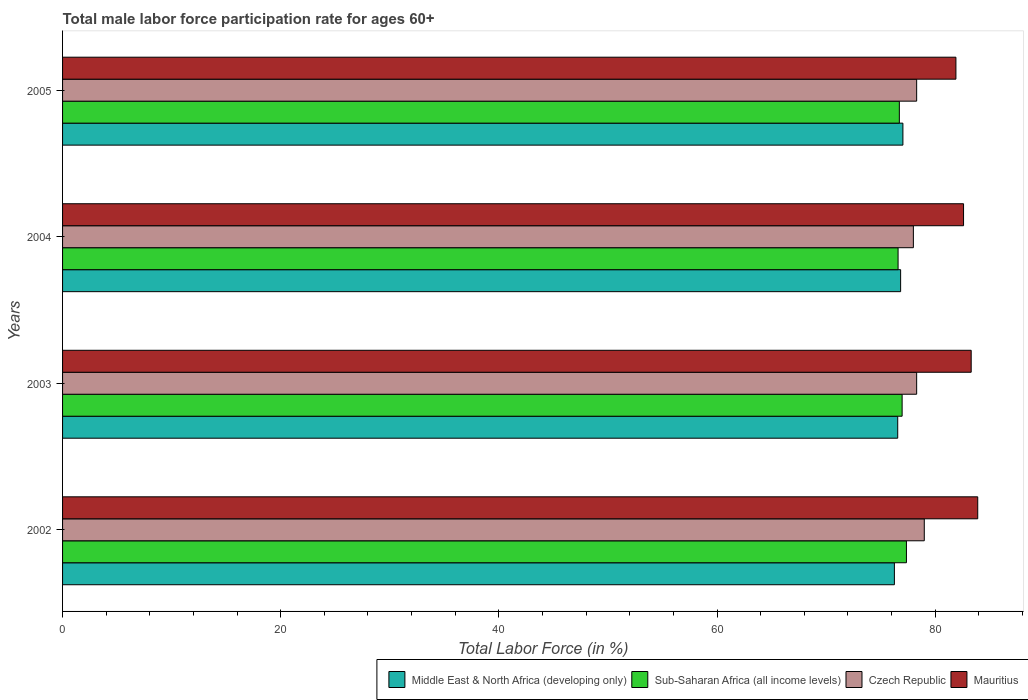How many bars are there on the 1st tick from the bottom?
Ensure brevity in your answer.  4. What is the male labor force participation rate in Sub-Saharan Africa (all income levels) in 2005?
Ensure brevity in your answer.  76.71. Across all years, what is the maximum male labor force participation rate in Sub-Saharan Africa (all income levels)?
Offer a terse response. 77.36. Across all years, what is the minimum male labor force participation rate in Czech Republic?
Your response must be concise. 78. What is the total male labor force participation rate in Sub-Saharan Africa (all income levels) in the graph?
Provide a short and direct response. 307.64. What is the difference between the male labor force participation rate in Middle East & North Africa (developing only) in 2002 and that in 2003?
Your answer should be very brief. -0.31. What is the difference between the male labor force participation rate in Czech Republic in 2005 and the male labor force participation rate in Middle East & North Africa (developing only) in 2002?
Provide a succinct answer. 2.04. What is the average male labor force participation rate in Middle East & North Africa (developing only) per year?
Your answer should be very brief. 76.67. In the year 2004, what is the difference between the male labor force participation rate in Mauritius and male labor force participation rate in Czech Republic?
Provide a succinct answer. 4.6. In how many years, is the male labor force participation rate in Sub-Saharan Africa (all income levels) greater than 72 %?
Your answer should be very brief. 4. What is the ratio of the male labor force participation rate in Middle East & North Africa (developing only) in 2004 to that in 2005?
Your answer should be very brief. 1. Is the male labor force participation rate in Mauritius in 2002 less than that in 2004?
Provide a succinct answer. No. Is the difference between the male labor force participation rate in Mauritius in 2002 and 2005 greater than the difference between the male labor force participation rate in Czech Republic in 2002 and 2005?
Your response must be concise. Yes. What is the difference between the highest and the second highest male labor force participation rate in Sub-Saharan Africa (all income levels)?
Keep it short and to the point. 0.4. What is the difference between the highest and the lowest male labor force participation rate in Mauritius?
Give a very brief answer. 2. In how many years, is the male labor force participation rate in Czech Republic greater than the average male labor force participation rate in Czech Republic taken over all years?
Offer a very short reply. 1. Is it the case that in every year, the sum of the male labor force participation rate in Sub-Saharan Africa (all income levels) and male labor force participation rate in Czech Republic is greater than the sum of male labor force participation rate in Middle East & North Africa (developing only) and male labor force participation rate in Mauritius?
Make the answer very short. No. What does the 2nd bar from the top in 2002 represents?
Your response must be concise. Czech Republic. What does the 2nd bar from the bottom in 2005 represents?
Your response must be concise. Sub-Saharan Africa (all income levels). Are all the bars in the graph horizontal?
Provide a succinct answer. Yes. What is the difference between two consecutive major ticks on the X-axis?
Your response must be concise. 20. Are the values on the major ticks of X-axis written in scientific E-notation?
Offer a very short reply. No. Does the graph contain any zero values?
Your answer should be very brief. No. How many legend labels are there?
Your response must be concise. 4. How are the legend labels stacked?
Provide a short and direct response. Horizontal. What is the title of the graph?
Provide a short and direct response. Total male labor force participation rate for ages 60+. What is the label or title of the X-axis?
Give a very brief answer. Total Labor Force (in %). What is the Total Labor Force (in %) of Middle East & North Africa (developing only) in 2002?
Give a very brief answer. 76.26. What is the Total Labor Force (in %) in Sub-Saharan Africa (all income levels) in 2002?
Provide a short and direct response. 77.36. What is the Total Labor Force (in %) in Czech Republic in 2002?
Give a very brief answer. 79. What is the Total Labor Force (in %) of Mauritius in 2002?
Ensure brevity in your answer.  83.9. What is the Total Labor Force (in %) in Middle East & North Africa (developing only) in 2003?
Provide a succinct answer. 76.57. What is the Total Labor Force (in %) of Sub-Saharan Africa (all income levels) in 2003?
Offer a terse response. 76.97. What is the Total Labor Force (in %) in Czech Republic in 2003?
Make the answer very short. 78.3. What is the Total Labor Force (in %) of Mauritius in 2003?
Ensure brevity in your answer.  83.3. What is the Total Labor Force (in %) in Middle East & North Africa (developing only) in 2004?
Give a very brief answer. 76.83. What is the Total Labor Force (in %) in Sub-Saharan Africa (all income levels) in 2004?
Make the answer very short. 76.6. What is the Total Labor Force (in %) of Mauritius in 2004?
Offer a terse response. 82.6. What is the Total Labor Force (in %) of Middle East & North Africa (developing only) in 2005?
Give a very brief answer. 77.04. What is the Total Labor Force (in %) of Sub-Saharan Africa (all income levels) in 2005?
Your response must be concise. 76.71. What is the Total Labor Force (in %) in Czech Republic in 2005?
Your answer should be very brief. 78.3. What is the Total Labor Force (in %) in Mauritius in 2005?
Ensure brevity in your answer.  81.9. Across all years, what is the maximum Total Labor Force (in %) in Middle East & North Africa (developing only)?
Provide a succinct answer. 77.04. Across all years, what is the maximum Total Labor Force (in %) in Sub-Saharan Africa (all income levels)?
Offer a very short reply. 77.36. Across all years, what is the maximum Total Labor Force (in %) of Czech Republic?
Provide a short and direct response. 79. Across all years, what is the maximum Total Labor Force (in %) of Mauritius?
Offer a very short reply. 83.9. Across all years, what is the minimum Total Labor Force (in %) of Middle East & North Africa (developing only)?
Provide a short and direct response. 76.26. Across all years, what is the minimum Total Labor Force (in %) of Sub-Saharan Africa (all income levels)?
Make the answer very short. 76.6. Across all years, what is the minimum Total Labor Force (in %) in Czech Republic?
Your answer should be very brief. 78. Across all years, what is the minimum Total Labor Force (in %) in Mauritius?
Provide a short and direct response. 81.9. What is the total Total Labor Force (in %) in Middle East & North Africa (developing only) in the graph?
Keep it short and to the point. 306.7. What is the total Total Labor Force (in %) of Sub-Saharan Africa (all income levels) in the graph?
Provide a succinct answer. 307.64. What is the total Total Labor Force (in %) in Czech Republic in the graph?
Your answer should be very brief. 313.6. What is the total Total Labor Force (in %) of Mauritius in the graph?
Your answer should be compact. 331.7. What is the difference between the Total Labor Force (in %) in Middle East & North Africa (developing only) in 2002 and that in 2003?
Provide a short and direct response. -0.31. What is the difference between the Total Labor Force (in %) in Sub-Saharan Africa (all income levels) in 2002 and that in 2003?
Give a very brief answer. 0.4. What is the difference between the Total Labor Force (in %) of Czech Republic in 2002 and that in 2003?
Give a very brief answer. 0.7. What is the difference between the Total Labor Force (in %) in Mauritius in 2002 and that in 2003?
Your answer should be compact. 0.6. What is the difference between the Total Labor Force (in %) in Middle East & North Africa (developing only) in 2002 and that in 2004?
Make the answer very short. -0.57. What is the difference between the Total Labor Force (in %) in Sub-Saharan Africa (all income levels) in 2002 and that in 2004?
Your answer should be compact. 0.77. What is the difference between the Total Labor Force (in %) in Czech Republic in 2002 and that in 2004?
Keep it short and to the point. 1. What is the difference between the Total Labor Force (in %) in Mauritius in 2002 and that in 2004?
Offer a terse response. 1.3. What is the difference between the Total Labor Force (in %) in Middle East & North Africa (developing only) in 2002 and that in 2005?
Ensure brevity in your answer.  -0.78. What is the difference between the Total Labor Force (in %) of Sub-Saharan Africa (all income levels) in 2002 and that in 2005?
Your answer should be very brief. 0.65. What is the difference between the Total Labor Force (in %) of Mauritius in 2002 and that in 2005?
Provide a succinct answer. 2. What is the difference between the Total Labor Force (in %) in Middle East & North Africa (developing only) in 2003 and that in 2004?
Provide a short and direct response. -0.27. What is the difference between the Total Labor Force (in %) in Sub-Saharan Africa (all income levels) in 2003 and that in 2004?
Ensure brevity in your answer.  0.37. What is the difference between the Total Labor Force (in %) of Mauritius in 2003 and that in 2004?
Your answer should be very brief. 0.7. What is the difference between the Total Labor Force (in %) of Middle East & North Africa (developing only) in 2003 and that in 2005?
Provide a short and direct response. -0.48. What is the difference between the Total Labor Force (in %) of Sub-Saharan Africa (all income levels) in 2003 and that in 2005?
Provide a short and direct response. 0.26. What is the difference between the Total Labor Force (in %) of Middle East & North Africa (developing only) in 2004 and that in 2005?
Keep it short and to the point. -0.21. What is the difference between the Total Labor Force (in %) in Sub-Saharan Africa (all income levels) in 2004 and that in 2005?
Provide a succinct answer. -0.12. What is the difference between the Total Labor Force (in %) of Czech Republic in 2004 and that in 2005?
Your response must be concise. -0.3. What is the difference between the Total Labor Force (in %) of Mauritius in 2004 and that in 2005?
Keep it short and to the point. 0.7. What is the difference between the Total Labor Force (in %) in Middle East & North Africa (developing only) in 2002 and the Total Labor Force (in %) in Sub-Saharan Africa (all income levels) in 2003?
Keep it short and to the point. -0.71. What is the difference between the Total Labor Force (in %) of Middle East & North Africa (developing only) in 2002 and the Total Labor Force (in %) of Czech Republic in 2003?
Provide a succinct answer. -2.04. What is the difference between the Total Labor Force (in %) of Middle East & North Africa (developing only) in 2002 and the Total Labor Force (in %) of Mauritius in 2003?
Ensure brevity in your answer.  -7.04. What is the difference between the Total Labor Force (in %) in Sub-Saharan Africa (all income levels) in 2002 and the Total Labor Force (in %) in Czech Republic in 2003?
Provide a succinct answer. -0.94. What is the difference between the Total Labor Force (in %) in Sub-Saharan Africa (all income levels) in 2002 and the Total Labor Force (in %) in Mauritius in 2003?
Provide a succinct answer. -5.94. What is the difference between the Total Labor Force (in %) of Czech Republic in 2002 and the Total Labor Force (in %) of Mauritius in 2003?
Your answer should be compact. -4.3. What is the difference between the Total Labor Force (in %) in Middle East & North Africa (developing only) in 2002 and the Total Labor Force (in %) in Sub-Saharan Africa (all income levels) in 2004?
Offer a terse response. -0.34. What is the difference between the Total Labor Force (in %) in Middle East & North Africa (developing only) in 2002 and the Total Labor Force (in %) in Czech Republic in 2004?
Ensure brevity in your answer.  -1.74. What is the difference between the Total Labor Force (in %) in Middle East & North Africa (developing only) in 2002 and the Total Labor Force (in %) in Mauritius in 2004?
Make the answer very short. -6.34. What is the difference between the Total Labor Force (in %) in Sub-Saharan Africa (all income levels) in 2002 and the Total Labor Force (in %) in Czech Republic in 2004?
Ensure brevity in your answer.  -0.64. What is the difference between the Total Labor Force (in %) in Sub-Saharan Africa (all income levels) in 2002 and the Total Labor Force (in %) in Mauritius in 2004?
Give a very brief answer. -5.24. What is the difference between the Total Labor Force (in %) in Czech Republic in 2002 and the Total Labor Force (in %) in Mauritius in 2004?
Offer a very short reply. -3.6. What is the difference between the Total Labor Force (in %) of Middle East & North Africa (developing only) in 2002 and the Total Labor Force (in %) of Sub-Saharan Africa (all income levels) in 2005?
Provide a short and direct response. -0.45. What is the difference between the Total Labor Force (in %) in Middle East & North Africa (developing only) in 2002 and the Total Labor Force (in %) in Czech Republic in 2005?
Provide a short and direct response. -2.04. What is the difference between the Total Labor Force (in %) of Middle East & North Africa (developing only) in 2002 and the Total Labor Force (in %) of Mauritius in 2005?
Provide a succinct answer. -5.64. What is the difference between the Total Labor Force (in %) of Sub-Saharan Africa (all income levels) in 2002 and the Total Labor Force (in %) of Czech Republic in 2005?
Ensure brevity in your answer.  -0.94. What is the difference between the Total Labor Force (in %) of Sub-Saharan Africa (all income levels) in 2002 and the Total Labor Force (in %) of Mauritius in 2005?
Provide a succinct answer. -4.54. What is the difference between the Total Labor Force (in %) of Czech Republic in 2002 and the Total Labor Force (in %) of Mauritius in 2005?
Offer a terse response. -2.9. What is the difference between the Total Labor Force (in %) in Middle East & North Africa (developing only) in 2003 and the Total Labor Force (in %) in Sub-Saharan Africa (all income levels) in 2004?
Your response must be concise. -0.03. What is the difference between the Total Labor Force (in %) of Middle East & North Africa (developing only) in 2003 and the Total Labor Force (in %) of Czech Republic in 2004?
Your answer should be compact. -1.44. What is the difference between the Total Labor Force (in %) of Middle East & North Africa (developing only) in 2003 and the Total Labor Force (in %) of Mauritius in 2004?
Provide a succinct answer. -6.04. What is the difference between the Total Labor Force (in %) of Sub-Saharan Africa (all income levels) in 2003 and the Total Labor Force (in %) of Czech Republic in 2004?
Make the answer very short. -1.03. What is the difference between the Total Labor Force (in %) of Sub-Saharan Africa (all income levels) in 2003 and the Total Labor Force (in %) of Mauritius in 2004?
Your answer should be very brief. -5.63. What is the difference between the Total Labor Force (in %) in Middle East & North Africa (developing only) in 2003 and the Total Labor Force (in %) in Sub-Saharan Africa (all income levels) in 2005?
Give a very brief answer. -0.15. What is the difference between the Total Labor Force (in %) in Middle East & North Africa (developing only) in 2003 and the Total Labor Force (in %) in Czech Republic in 2005?
Your answer should be compact. -1.74. What is the difference between the Total Labor Force (in %) in Middle East & North Africa (developing only) in 2003 and the Total Labor Force (in %) in Mauritius in 2005?
Provide a succinct answer. -5.33. What is the difference between the Total Labor Force (in %) in Sub-Saharan Africa (all income levels) in 2003 and the Total Labor Force (in %) in Czech Republic in 2005?
Make the answer very short. -1.33. What is the difference between the Total Labor Force (in %) in Sub-Saharan Africa (all income levels) in 2003 and the Total Labor Force (in %) in Mauritius in 2005?
Give a very brief answer. -4.93. What is the difference between the Total Labor Force (in %) in Czech Republic in 2003 and the Total Labor Force (in %) in Mauritius in 2005?
Offer a terse response. -3.6. What is the difference between the Total Labor Force (in %) in Middle East & North Africa (developing only) in 2004 and the Total Labor Force (in %) in Sub-Saharan Africa (all income levels) in 2005?
Give a very brief answer. 0.12. What is the difference between the Total Labor Force (in %) in Middle East & North Africa (developing only) in 2004 and the Total Labor Force (in %) in Czech Republic in 2005?
Give a very brief answer. -1.47. What is the difference between the Total Labor Force (in %) in Middle East & North Africa (developing only) in 2004 and the Total Labor Force (in %) in Mauritius in 2005?
Make the answer very short. -5.07. What is the difference between the Total Labor Force (in %) in Sub-Saharan Africa (all income levels) in 2004 and the Total Labor Force (in %) in Czech Republic in 2005?
Your response must be concise. -1.7. What is the difference between the Total Labor Force (in %) of Sub-Saharan Africa (all income levels) in 2004 and the Total Labor Force (in %) of Mauritius in 2005?
Offer a very short reply. -5.3. What is the difference between the Total Labor Force (in %) of Czech Republic in 2004 and the Total Labor Force (in %) of Mauritius in 2005?
Give a very brief answer. -3.9. What is the average Total Labor Force (in %) of Middle East & North Africa (developing only) per year?
Provide a short and direct response. 76.67. What is the average Total Labor Force (in %) in Sub-Saharan Africa (all income levels) per year?
Provide a short and direct response. 76.91. What is the average Total Labor Force (in %) in Czech Republic per year?
Offer a terse response. 78.4. What is the average Total Labor Force (in %) of Mauritius per year?
Your response must be concise. 82.92. In the year 2002, what is the difference between the Total Labor Force (in %) in Middle East & North Africa (developing only) and Total Labor Force (in %) in Sub-Saharan Africa (all income levels)?
Give a very brief answer. -1.1. In the year 2002, what is the difference between the Total Labor Force (in %) of Middle East & North Africa (developing only) and Total Labor Force (in %) of Czech Republic?
Give a very brief answer. -2.74. In the year 2002, what is the difference between the Total Labor Force (in %) of Middle East & North Africa (developing only) and Total Labor Force (in %) of Mauritius?
Offer a terse response. -7.64. In the year 2002, what is the difference between the Total Labor Force (in %) in Sub-Saharan Africa (all income levels) and Total Labor Force (in %) in Czech Republic?
Provide a short and direct response. -1.64. In the year 2002, what is the difference between the Total Labor Force (in %) of Sub-Saharan Africa (all income levels) and Total Labor Force (in %) of Mauritius?
Make the answer very short. -6.54. In the year 2002, what is the difference between the Total Labor Force (in %) in Czech Republic and Total Labor Force (in %) in Mauritius?
Give a very brief answer. -4.9. In the year 2003, what is the difference between the Total Labor Force (in %) in Middle East & North Africa (developing only) and Total Labor Force (in %) in Sub-Saharan Africa (all income levels)?
Provide a short and direct response. -0.4. In the year 2003, what is the difference between the Total Labor Force (in %) in Middle East & North Africa (developing only) and Total Labor Force (in %) in Czech Republic?
Keep it short and to the point. -1.74. In the year 2003, what is the difference between the Total Labor Force (in %) in Middle East & North Africa (developing only) and Total Labor Force (in %) in Mauritius?
Your answer should be compact. -6.74. In the year 2003, what is the difference between the Total Labor Force (in %) of Sub-Saharan Africa (all income levels) and Total Labor Force (in %) of Czech Republic?
Provide a succinct answer. -1.33. In the year 2003, what is the difference between the Total Labor Force (in %) in Sub-Saharan Africa (all income levels) and Total Labor Force (in %) in Mauritius?
Your answer should be compact. -6.33. In the year 2004, what is the difference between the Total Labor Force (in %) in Middle East & North Africa (developing only) and Total Labor Force (in %) in Sub-Saharan Africa (all income levels)?
Your answer should be very brief. 0.23. In the year 2004, what is the difference between the Total Labor Force (in %) in Middle East & North Africa (developing only) and Total Labor Force (in %) in Czech Republic?
Make the answer very short. -1.17. In the year 2004, what is the difference between the Total Labor Force (in %) in Middle East & North Africa (developing only) and Total Labor Force (in %) in Mauritius?
Keep it short and to the point. -5.77. In the year 2004, what is the difference between the Total Labor Force (in %) in Sub-Saharan Africa (all income levels) and Total Labor Force (in %) in Czech Republic?
Your answer should be very brief. -1.4. In the year 2004, what is the difference between the Total Labor Force (in %) of Sub-Saharan Africa (all income levels) and Total Labor Force (in %) of Mauritius?
Keep it short and to the point. -6. In the year 2004, what is the difference between the Total Labor Force (in %) of Czech Republic and Total Labor Force (in %) of Mauritius?
Your response must be concise. -4.6. In the year 2005, what is the difference between the Total Labor Force (in %) in Middle East & North Africa (developing only) and Total Labor Force (in %) in Sub-Saharan Africa (all income levels)?
Provide a succinct answer. 0.33. In the year 2005, what is the difference between the Total Labor Force (in %) of Middle East & North Africa (developing only) and Total Labor Force (in %) of Czech Republic?
Make the answer very short. -1.26. In the year 2005, what is the difference between the Total Labor Force (in %) of Middle East & North Africa (developing only) and Total Labor Force (in %) of Mauritius?
Keep it short and to the point. -4.86. In the year 2005, what is the difference between the Total Labor Force (in %) in Sub-Saharan Africa (all income levels) and Total Labor Force (in %) in Czech Republic?
Your response must be concise. -1.59. In the year 2005, what is the difference between the Total Labor Force (in %) in Sub-Saharan Africa (all income levels) and Total Labor Force (in %) in Mauritius?
Make the answer very short. -5.19. What is the ratio of the Total Labor Force (in %) in Sub-Saharan Africa (all income levels) in 2002 to that in 2003?
Your answer should be very brief. 1.01. What is the ratio of the Total Labor Force (in %) in Czech Republic in 2002 to that in 2003?
Offer a very short reply. 1.01. What is the ratio of the Total Labor Force (in %) of Middle East & North Africa (developing only) in 2002 to that in 2004?
Make the answer very short. 0.99. What is the ratio of the Total Labor Force (in %) of Czech Republic in 2002 to that in 2004?
Keep it short and to the point. 1.01. What is the ratio of the Total Labor Force (in %) in Mauritius in 2002 to that in 2004?
Your answer should be very brief. 1.02. What is the ratio of the Total Labor Force (in %) in Sub-Saharan Africa (all income levels) in 2002 to that in 2005?
Ensure brevity in your answer.  1.01. What is the ratio of the Total Labor Force (in %) of Czech Republic in 2002 to that in 2005?
Give a very brief answer. 1.01. What is the ratio of the Total Labor Force (in %) in Mauritius in 2002 to that in 2005?
Provide a succinct answer. 1.02. What is the ratio of the Total Labor Force (in %) of Middle East & North Africa (developing only) in 2003 to that in 2004?
Offer a very short reply. 1. What is the ratio of the Total Labor Force (in %) of Sub-Saharan Africa (all income levels) in 2003 to that in 2004?
Give a very brief answer. 1. What is the ratio of the Total Labor Force (in %) in Czech Republic in 2003 to that in 2004?
Keep it short and to the point. 1. What is the ratio of the Total Labor Force (in %) of Mauritius in 2003 to that in 2004?
Provide a short and direct response. 1.01. What is the ratio of the Total Labor Force (in %) in Middle East & North Africa (developing only) in 2003 to that in 2005?
Offer a terse response. 0.99. What is the ratio of the Total Labor Force (in %) of Sub-Saharan Africa (all income levels) in 2003 to that in 2005?
Give a very brief answer. 1. What is the ratio of the Total Labor Force (in %) in Mauritius in 2003 to that in 2005?
Give a very brief answer. 1.02. What is the ratio of the Total Labor Force (in %) of Middle East & North Africa (developing only) in 2004 to that in 2005?
Provide a short and direct response. 1. What is the ratio of the Total Labor Force (in %) in Czech Republic in 2004 to that in 2005?
Offer a very short reply. 1. What is the ratio of the Total Labor Force (in %) of Mauritius in 2004 to that in 2005?
Your answer should be very brief. 1.01. What is the difference between the highest and the second highest Total Labor Force (in %) in Middle East & North Africa (developing only)?
Provide a succinct answer. 0.21. What is the difference between the highest and the second highest Total Labor Force (in %) of Sub-Saharan Africa (all income levels)?
Your response must be concise. 0.4. What is the difference between the highest and the second highest Total Labor Force (in %) in Czech Republic?
Make the answer very short. 0.7. What is the difference between the highest and the second highest Total Labor Force (in %) in Mauritius?
Your answer should be compact. 0.6. What is the difference between the highest and the lowest Total Labor Force (in %) of Middle East & North Africa (developing only)?
Provide a short and direct response. 0.78. What is the difference between the highest and the lowest Total Labor Force (in %) of Sub-Saharan Africa (all income levels)?
Your answer should be very brief. 0.77. What is the difference between the highest and the lowest Total Labor Force (in %) in Czech Republic?
Keep it short and to the point. 1. 